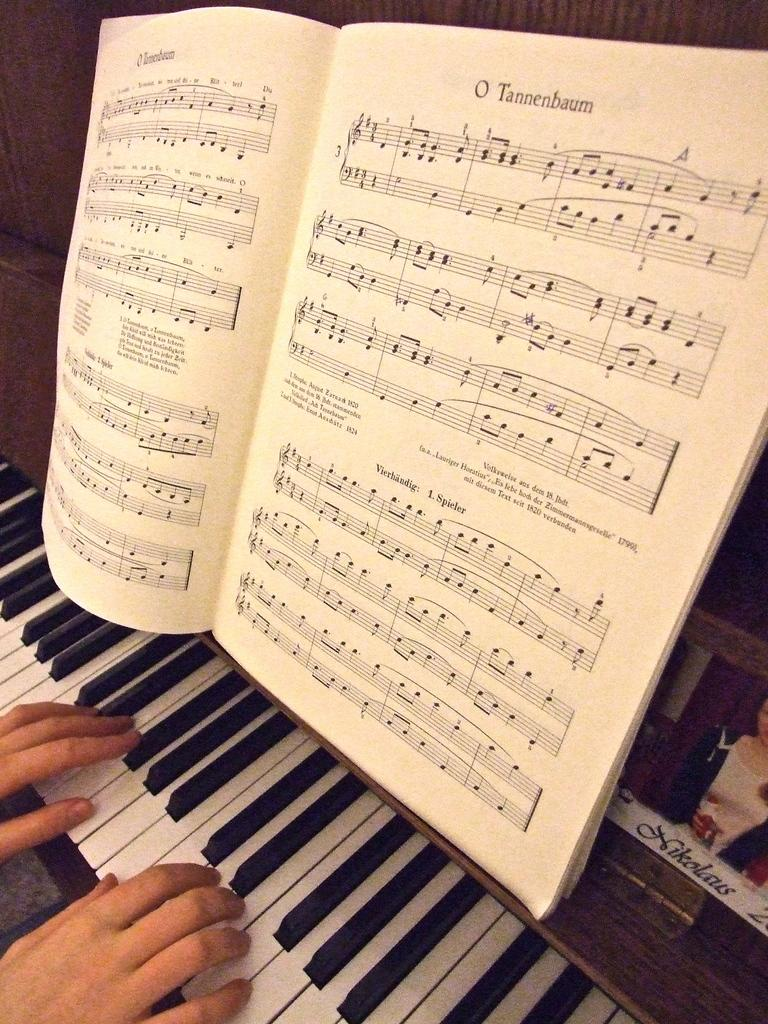What is the person doing in the image? A person's hand is visible in the left bottom of the image, playing a keyboard. What object is placed on the table in the image? There is a book in the foreground of the image, placed on a table. Where was the image taken? The image is taken inside a room. What color is the locket hanging from the person's neck in the image? There is no locket visible in the image; only a person's hand playing a keyboard and a book on a table are present. 